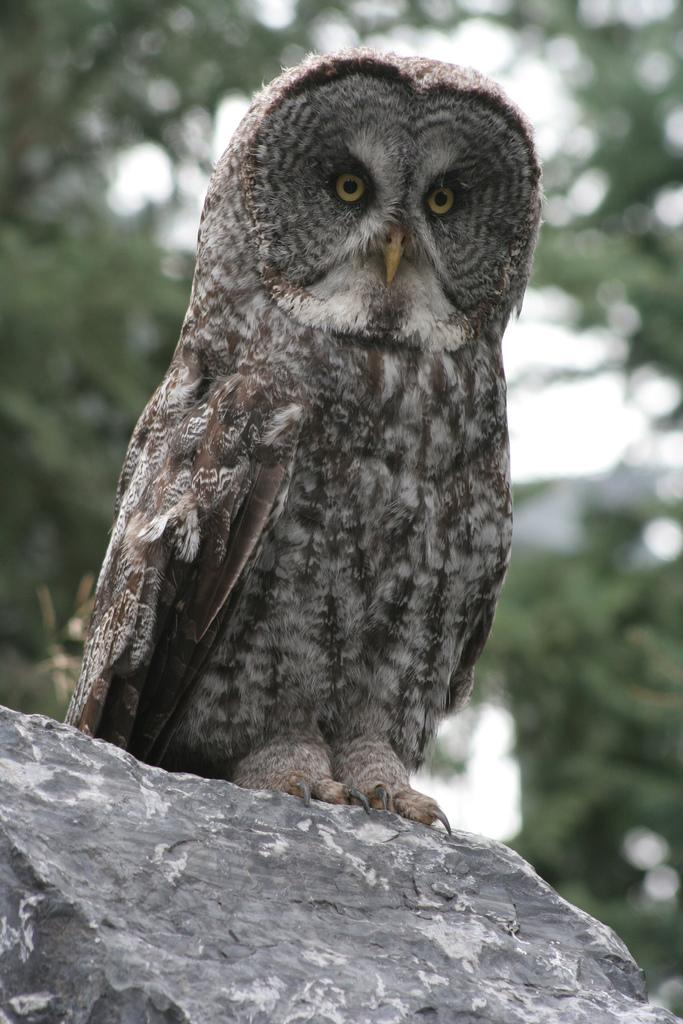What animal is in the image? There is an owl in the image. Where is the owl located? The owl is on a rock. What can be seen in the background of the image? There are trees and the sky visible in the background of the image. What is the color of the trees in the image? The trees are green. What is the color of the sky in the image? The sky is white in color. How does the owl compare to a knot in the image? There is no knot present in the image, so it cannot be compared to the owl. 